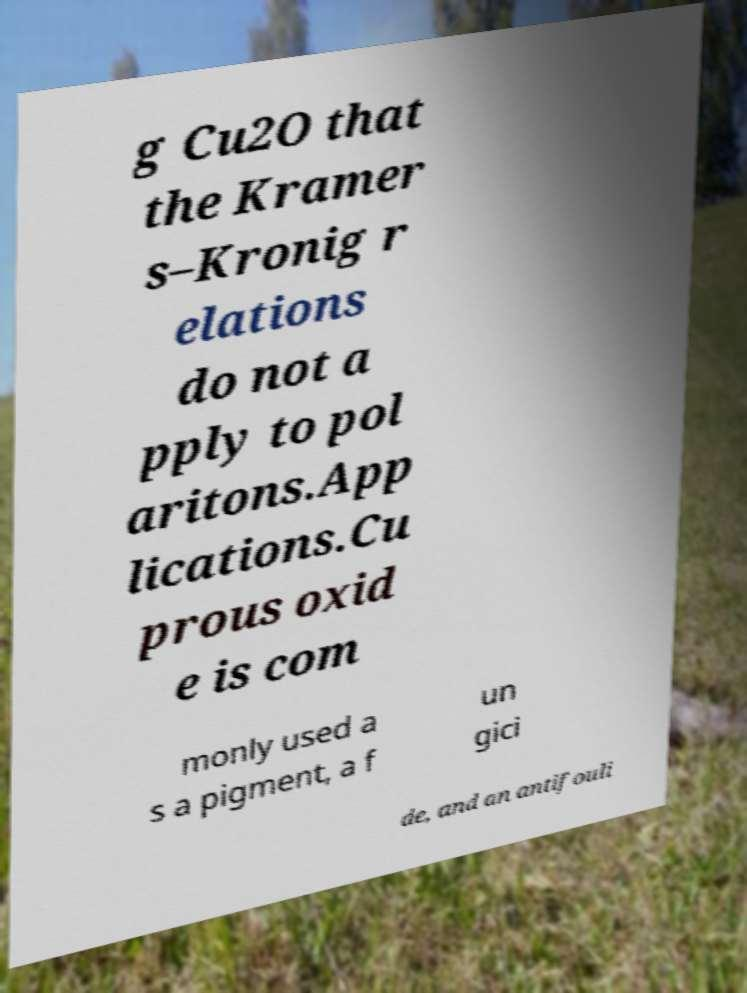Can you read and provide the text displayed in the image?This photo seems to have some interesting text. Can you extract and type it out for me? g Cu2O that the Kramer s–Kronig r elations do not a pply to pol aritons.App lications.Cu prous oxid e is com monly used a s a pigment, a f un gici de, and an antifouli 